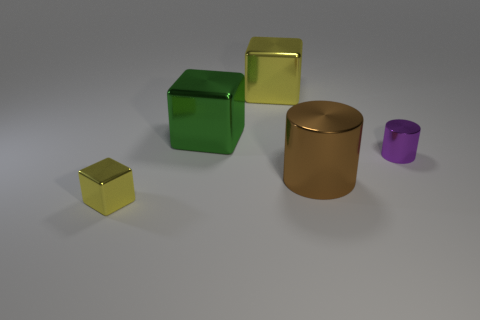There is a block that is the same size as the green object; what is it made of?
Keep it short and to the point. Metal. Is there a yellow object made of the same material as the tiny yellow cube?
Offer a terse response. Yes. What shape is the small metallic object to the right of the big yellow shiny cube that is to the left of the tiny thing that is behind the small yellow object?
Your answer should be very brief. Cylinder. Is the size of the brown metallic object the same as the yellow cube in front of the big yellow metal object?
Your answer should be very brief. No. The object that is both in front of the large green metallic block and on the left side of the big yellow block has what shape?
Make the answer very short. Cube. How many large things are brown metallic blocks or cylinders?
Your answer should be compact. 1. Are there an equal number of big metal objects that are in front of the tiny purple shiny object and large yellow metallic blocks that are on the left side of the big yellow object?
Your response must be concise. No. What number of other objects are there of the same color as the large metallic cylinder?
Give a very brief answer. 0. Is the number of purple metallic things that are behind the purple metallic thing the same as the number of gray rubber cylinders?
Your answer should be compact. Yes. Is the brown metal thing the same size as the green cube?
Make the answer very short. Yes. 